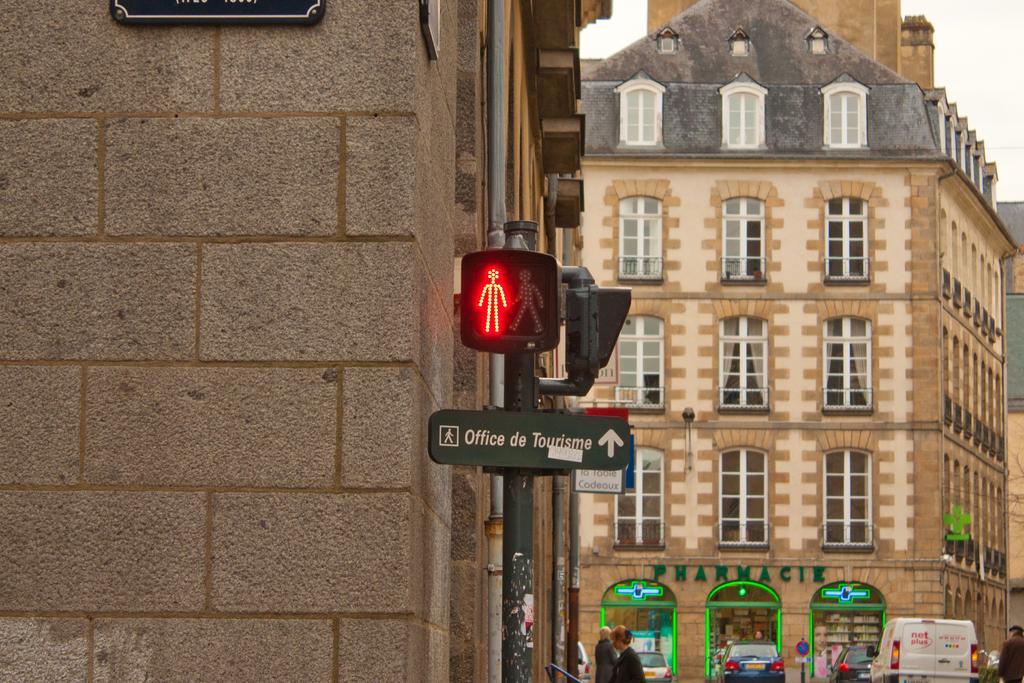What is the main object in the image? There is a pole in the image. What is attached to the pole? A pedestrian signal is present on the pole. What can be seen in the background of the image? There are buildings visible in the image. What type of sponge can be seen hanging from the pole in the image? There is no sponge present in the image; it features a pole with a pedestrian signal and buildings in the background. 